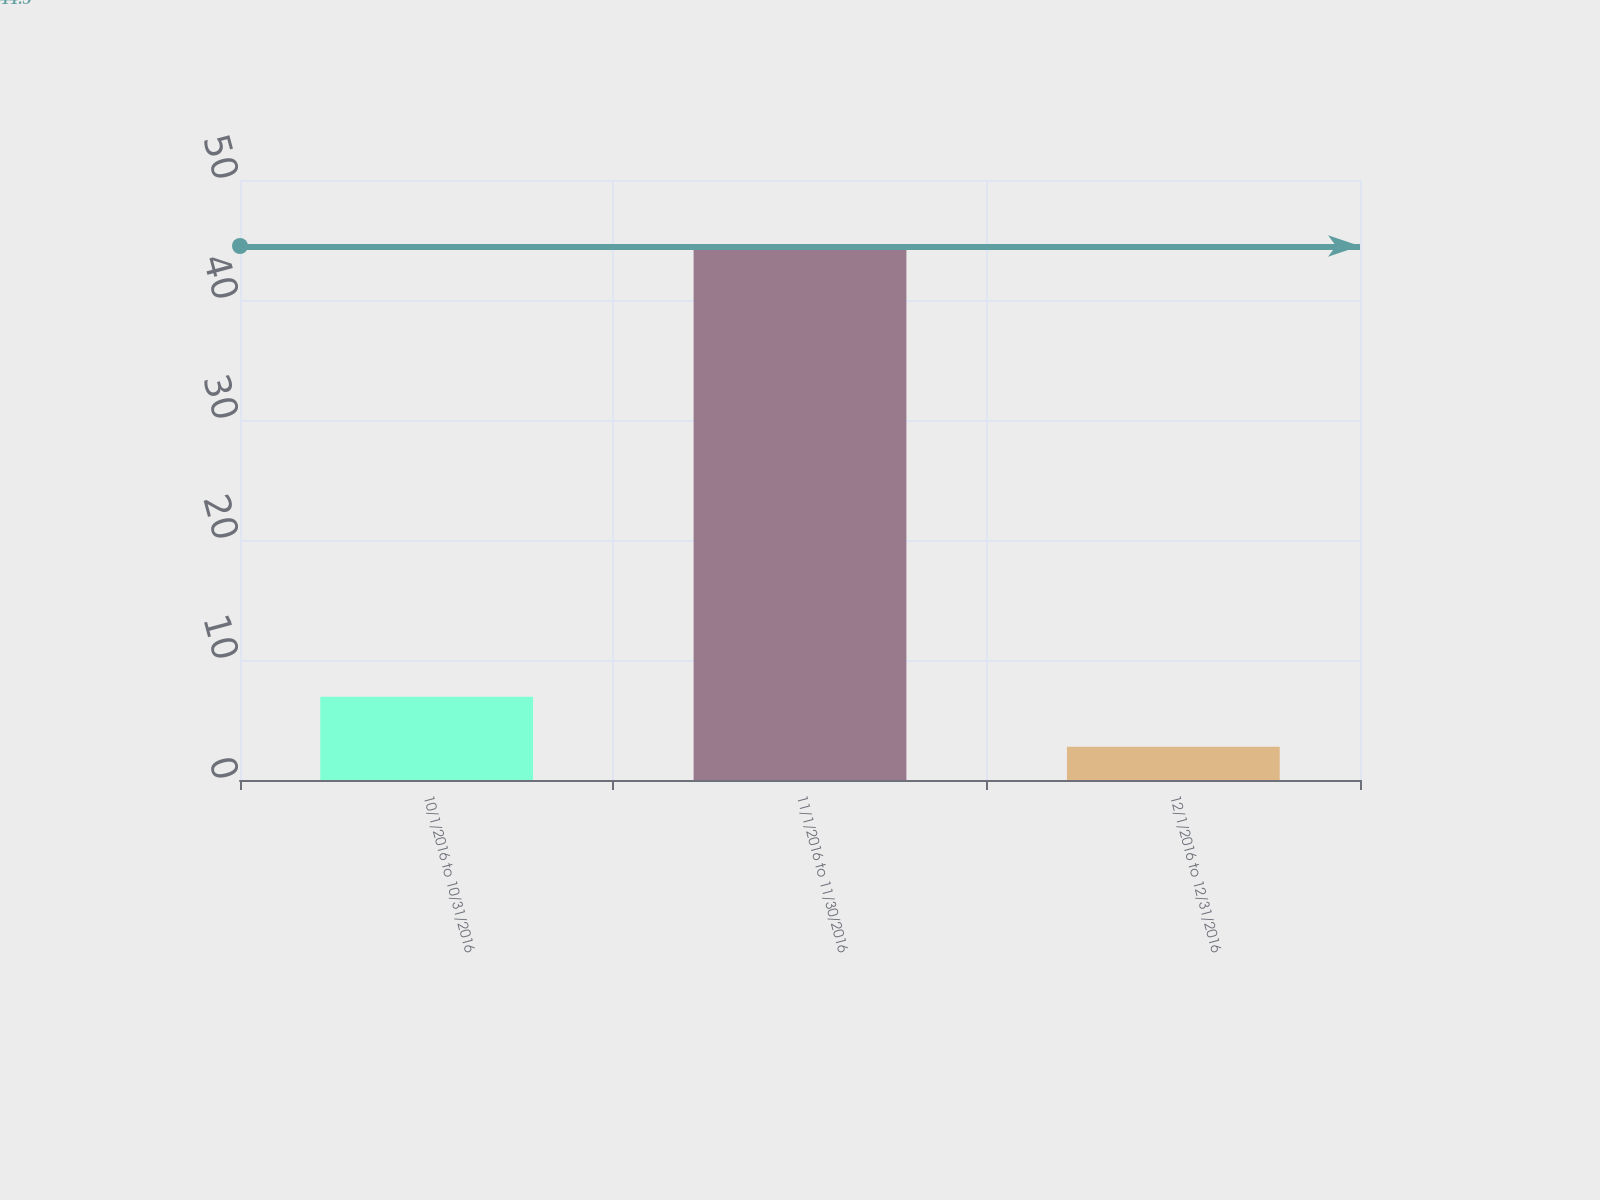Convert chart to OTSL. <chart><loc_0><loc_0><loc_500><loc_500><bar_chart><fcel>10/1/2016 to 10/31/2016<fcel>11/1/2016 to 11/30/2016<fcel>12/1/2016 to 12/31/2016<nl><fcel>6.94<fcel>44.5<fcel>2.77<nl></chart> 